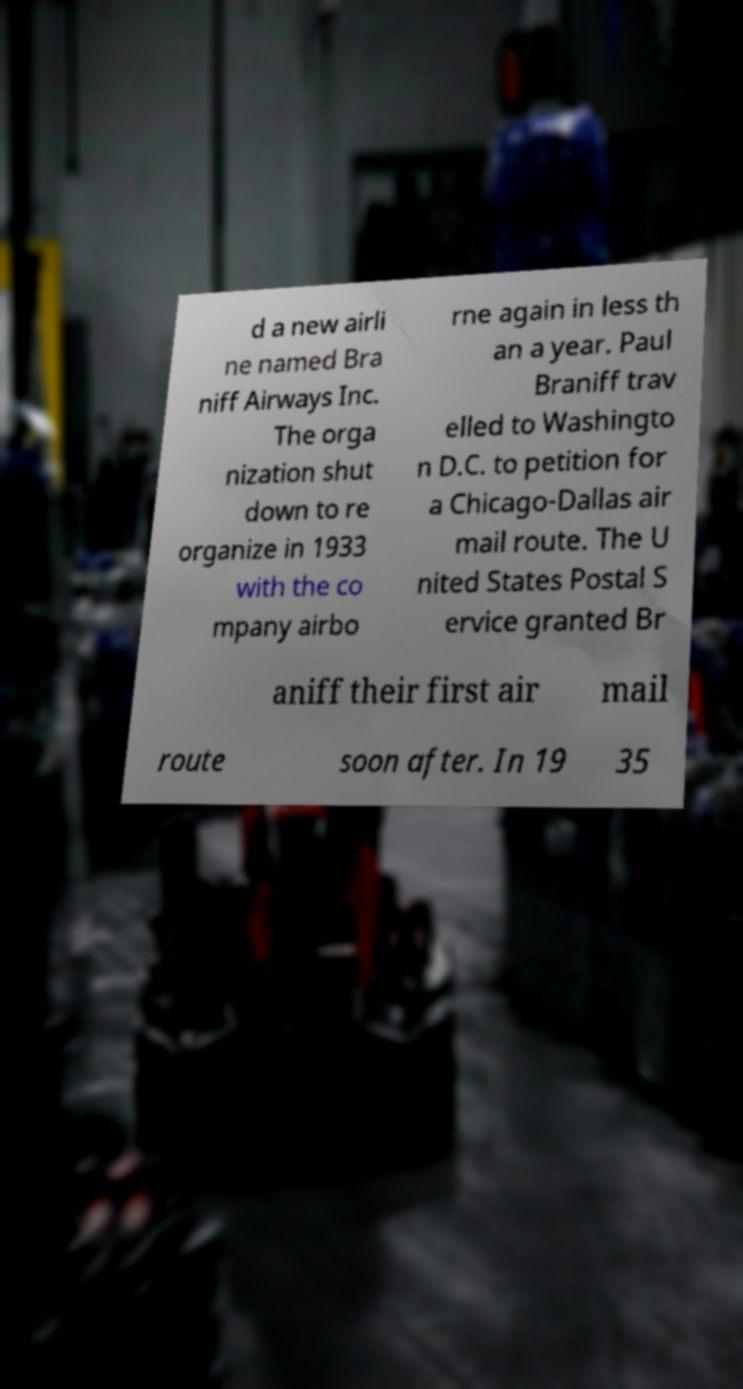For documentation purposes, I need the text within this image transcribed. Could you provide that? d a new airli ne named Bra niff Airways Inc. The orga nization shut down to re organize in 1933 with the co mpany airbo rne again in less th an a year. Paul Braniff trav elled to Washingto n D.C. to petition for a Chicago-Dallas air mail route. The U nited States Postal S ervice granted Br aniff their first air mail route soon after. In 19 35 